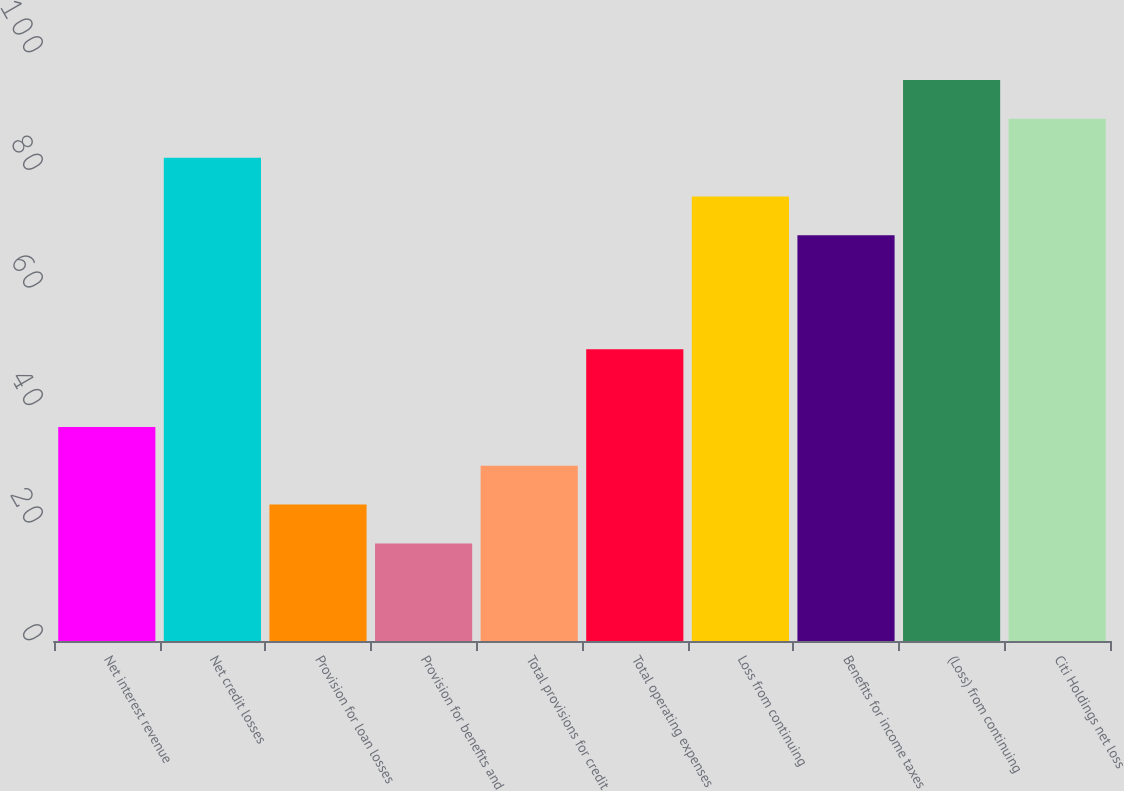Convert chart to OTSL. <chart><loc_0><loc_0><loc_500><loc_500><bar_chart><fcel>Net interest revenue<fcel>Net credit losses<fcel>Provision for loan losses<fcel>Provision for benefits and<fcel>Total provisions for credit<fcel>Total operating expenses<fcel>Loss from continuing<fcel>Benefits for income taxes<fcel>(Loss) from continuing<fcel>Citi Holdings net loss<nl><fcel>36.4<fcel>82.2<fcel>23.2<fcel>16.6<fcel>29.8<fcel>49.6<fcel>75.6<fcel>69<fcel>95.4<fcel>88.8<nl></chart> 